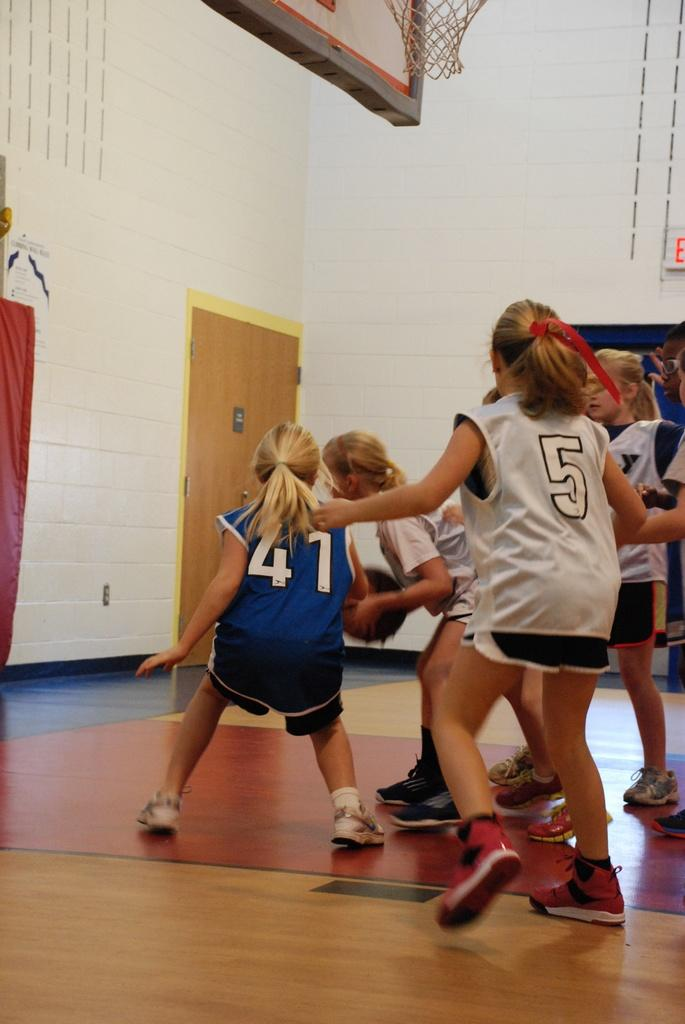<image>
Create a compact narrative representing the image presented. a group of players playing basketball with one girl wearing 41 